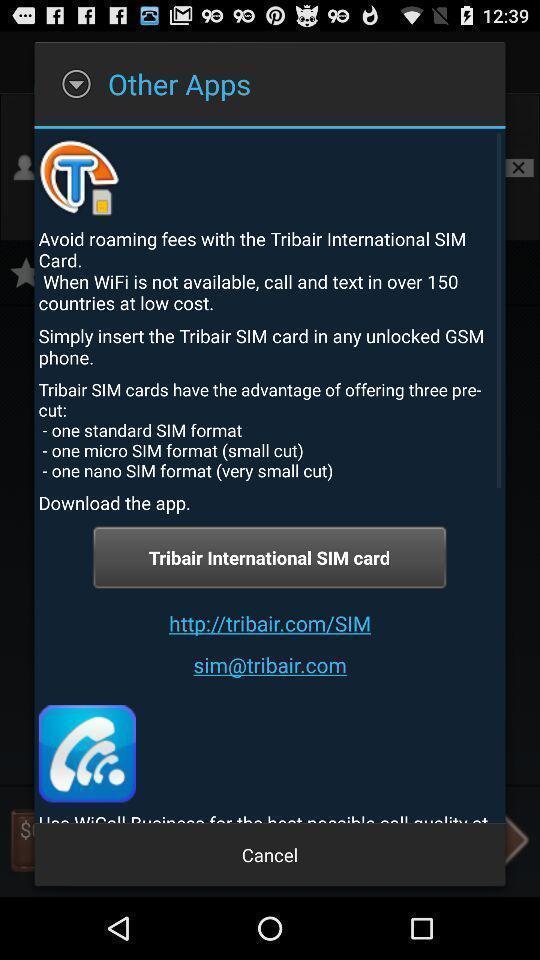Explain the elements present in this screenshot. Pop-up showing different application to download. 